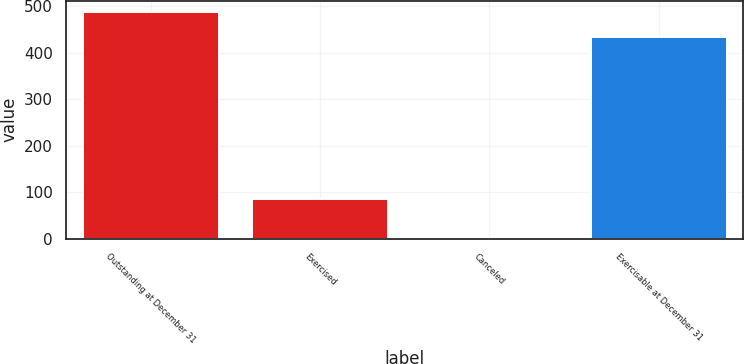Convert chart to OTSL. <chart><loc_0><loc_0><loc_500><loc_500><bar_chart><fcel>Outstanding at December 31<fcel>Exercised<fcel>Canceled<fcel>Exercisable at December 31<nl><fcel>487.8<fcel>85<fcel>1<fcel>433<nl></chart> 